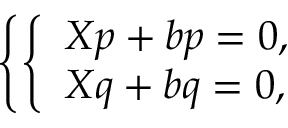Convert formula to latex. <formula><loc_0><loc_0><loc_500><loc_500>\left \{ \left \{ \begin{array} { l l } { X p + b p = 0 , } \\ { X q + b q = 0 , } \end{array}</formula> 